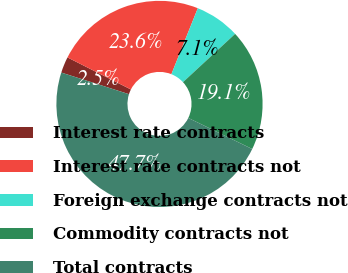Convert chart to OTSL. <chart><loc_0><loc_0><loc_500><loc_500><pie_chart><fcel>Interest rate contracts<fcel>Interest rate contracts not<fcel>Foreign exchange contracts not<fcel>Commodity contracts not<fcel>Total contracts<nl><fcel>2.53%<fcel>23.61%<fcel>7.05%<fcel>19.09%<fcel>47.72%<nl></chart> 